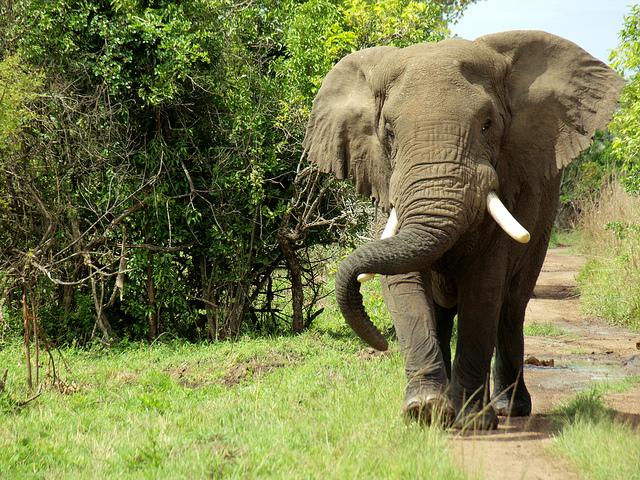What is behind the elephant?
Be succinct. Trees. How many tusks does the elephant have?
Be succinct. 2. How does the elephant feel?
Be succinct. Happy. How many ants is the elephant stomping on?
Give a very brief answer. Lot. 